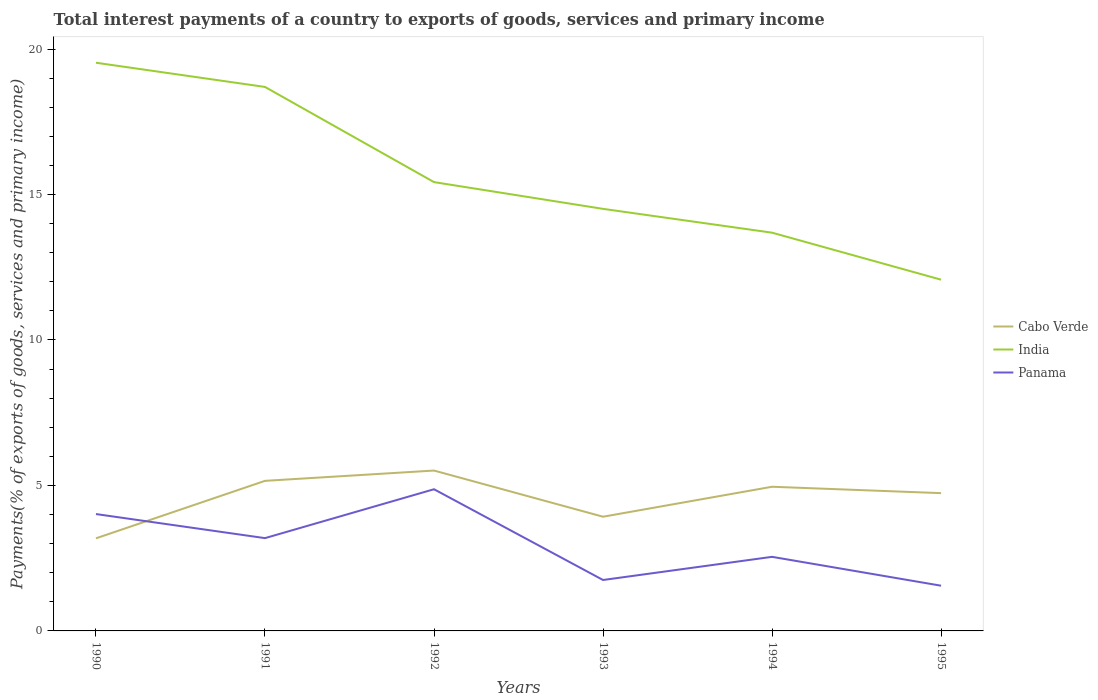Does the line corresponding to India intersect with the line corresponding to Cabo Verde?
Offer a very short reply. No. Across all years, what is the maximum total interest payments in Cabo Verde?
Keep it short and to the point. 3.18. What is the total total interest payments in Panama in the graph?
Make the answer very short. 2.27. What is the difference between the highest and the second highest total interest payments in Panama?
Keep it short and to the point. 3.32. What is the difference between two consecutive major ticks on the Y-axis?
Your answer should be very brief. 5. Does the graph contain any zero values?
Ensure brevity in your answer.  No. Where does the legend appear in the graph?
Make the answer very short. Center right. What is the title of the graph?
Keep it short and to the point. Total interest payments of a country to exports of goods, services and primary income. What is the label or title of the Y-axis?
Your response must be concise. Payments(% of exports of goods, services and primary income). What is the Payments(% of exports of goods, services and primary income) in Cabo Verde in 1990?
Provide a short and direct response. 3.18. What is the Payments(% of exports of goods, services and primary income) of India in 1990?
Give a very brief answer. 19.53. What is the Payments(% of exports of goods, services and primary income) of Panama in 1990?
Keep it short and to the point. 4.02. What is the Payments(% of exports of goods, services and primary income) in Cabo Verde in 1991?
Offer a terse response. 5.16. What is the Payments(% of exports of goods, services and primary income) of India in 1991?
Your response must be concise. 18.7. What is the Payments(% of exports of goods, services and primary income) of Panama in 1991?
Provide a short and direct response. 3.19. What is the Payments(% of exports of goods, services and primary income) in Cabo Verde in 1992?
Provide a succinct answer. 5.51. What is the Payments(% of exports of goods, services and primary income) in India in 1992?
Provide a succinct answer. 15.43. What is the Payments(% of exports of goods, services and primary income) in Panama in 1992?
Offer a very short reply. 4.87. What is the Payments(% of exports of goods, services and primary income) in Cabo Verde in 1993?
Provide a short and direct response. 3.93. What is the Payments(% of exports of goods, services and primary income) of India in 1993?
Ensure brevity in your answer.  14.51. What is the Payments(% of exports of goods, services and primary income) of Panama in 1993?
Ensure brevity in your answer.  1.75. What is the Payments(% of exports of goods, services and primary income) of Cabo Verde in 1994?
Ensure brevity in your answer.  4.96. What is the Payments(% of exports of goods, services and primary income) in India in 1994?
Your answer should be compact. 13.69. What is the Payments(% of exports of goods, services and primary income) of Panama in 1994?
Keep it short and to the point. 2.55. What is the Payments(% of exports of goods, services and primary income) in Cabo Verde in 1995?
Your answer should be compact. 4.74. What is the Payments(% of exports of goods, services and primary income) of India in 1995?
Your answer should be compact. 12.07. What is the Payments(% of exports of goods, services and primary income) in Panama in 1995?
Make the answer very short. 1.55. Across all years, what is the maximum Payments(% of exports of goods, services and primary income) in Cabo Verde?
Offer a terse response. 5.51. Across all years, what is the maximum Payments(% of exports of goods, services and primary income) of India?
Your answer should be compact. 19.53. Across all years, what is the maximum Payments(% of exports of goods, services and primary income) of Panama?
Make the answer very short. 4.87. Across all years, what is the minimum Payments(% of exports of goods, services and primary income) of Cabo Verde?
Provide a short and direct response. 3.18. Across all years, what is the minimum Payments(% of exports of goods, services and primary income) in India?
Offer a very short reply. 12.07. Across all years, what is the minimum Payments(% of exports of goods, services and primary income) in Panama?
Make the answer very short. 1.55. What is the total Payments(% of exports of goods, services and primary income) in Cabo Verde in the graph?
Keep it short and to the point. 27.47. What is the total Payments(% of exports of goods, services and primary income) of India in the graph?
Give a very brief answer. 93.93. What is the total Payments(% of exports of goods, services and primary income) of Panama in the graph?
Your answer should be very brief. 17.93. What is the difference between the Payments(% of exports of goods, services and primary income) in Cabo Verde in 1990 and that in 1991?
Provide a succinct answer. -1.98. What is the difference between the Payments(% of exports of goods, services and primary income) in India in 1990 and that in 1991?
Ensure brevity in your answer.  0.83. What is the difference between the Payments(% of exports of goods, services and primary income) in Panama in 1990 and that in 1991?
Give a very brief answer. 0.83. What is the difference between the Payments(% of exports of goods, services and primary income) in Cabo Verde in 1990 and that in 1992?
Your answer should be compact. -2.33. What is the difference between the Payments(% of exports of goods, services and primary income) of India in 1990 and that in 1992?
Provide a succinct answer. 4.1. What is the difference between the Payments(% of exports of goods, services and primary income) in Panama in 1990 and that in 1992?
Provide a succinct answer. -0.85. What is the difference between the Payments(% of exports of goods, services and primary income) of Cabo Verde in 1990 and that in 1993?
Provide a succinct answer. -0.74. What is the difference between the Payments(% of exports of goods, services and primary income) in India in 1990 and that in 1993?
Ensure brevity in your answer.  5.02. What is the difference between the Payments(% of exports of goods, services and primary income) in Panama in 1990 and that in 1993?
Ensure brevity in your answer.  2.27. What is the difference between the Payments(% of exports of goods, services and primary income) in Cabo Verde in 1990 and that in 1994?
Offer a terse response. -1.77. What is the difference between the Payments(% of exports of goods, services and primary income) of India in 1990 and that in 1994?
Your answer should be compact. 5.84. What is the difference between the Payments(% of exports of goods, services and primary income) in Panama in 1990 and that in 1994?
Your answer should be very brief. 1.47. What is the difference between the Payments(% of exports of goods, services and primary income) of Cabo Verde in 1990 and that in 1995?
Your response must be concise. -1.55. What is the difference between the Payments(% of exports of goods, services and primary income) of India in 1990 and that in 1995?
Your response must be concise. 7.46. What is the difference between the Payments(% of exports of goods, services and primary income) of Panama in 1990 and that in 1995?
Your response must be concise. 2.46. What is the difference between the Payments(% of exports of goods, services and primary income) in Cabo Verde in 1991 and that in 1992?
Keep it short and to the point. -0.35. What is the difference between the Payments(% of exports of goods, services and primary income) in India in 1991 and that in 1992?
Provide a succinct answer. 3.27. What is the difference between the Payments(% of exports of goods, services and primary income) in Panama in 1991 and that in 1992?
Keep it short and to the point. -1.68. What is the difference between the Payments(% of exports of goods, services and primary income) of Cabo Verde in 1991 and that in 1993?
Provide a short and direct response. 1.23. What is the difference between the Payments(% of exports of goods, services and primary income) in India in 1991 and that in 1993?
Offer a very short reply. 4.19. What is the difference between the Payments(% of exports of goods, services and primary income) in Panama in 1991 and that in 1993?
Your answer should be very brief. 1.44. What is the difference between the Payments(% of exports of goods, services and primary income) in Cabo Verde in 1991 and that in 1994?
Give a very brief answer. 0.2. What is the difference between the Payments(% of exports of goods, services and primary income) in India in 1991 and that in 1994?
Provide a succinct answer. 5.01. What is the difference between the Payments(% of exports of goods, services and primary income) of Panama in 1991 and that in 1994?
Your answer should be compact. 0.64. What is the difference between the Payments(% of exports of goods, services and primary income) in Cabo Verde in 1991 and that in 1995?
Ensure brevity in your answer.  0.42. What is the difference between the Payments(% of exports of goods, services and primary income) of India in 1991 and that in 1995?
Provide a short and direct response. 6.63. What is the difference between the Payments(% of exports of goods, services and primary income) in Panama in 1991 and that in 1995?
Provide a short and direct response. 1.64. What is the difference between the Payments(% of exports of goods, services and primary income) in Cabo Verde in 1992 and that in 1993?
Make the answer very short. 1.59. What is the difference between the Payments(% of exports of goods, services and primary income) in India in 1992 and that in 1993?
Give a very brief answer. 0.92. What is the difference between the Payments(% of exports of goods, services and primary income) in Panama in 1992 and that in 1993?
Provide a short and direct response. 3.12. What is the difference between the Payments(% of exports of goods, services and primary income) of Cabo Verde in 1992 and that in 1994?
Provide a short and direct response. 0.56. What is the difference between the Payments(% of exports of goods, services and primary income) of India in 1992 and that in 1994?
Provide a short and direct response. 1.74. What is the difference between the Payments(% of exports of goods, services and primary income) of Panama in 1992 and that in 1994?
Your answer should be compact. 2.32. What is the difference between the Payments(% of exports of goods, services and primary income) in Cabo Verde in 1992 and that in 1995?
Offer a very short reply. 0.78. What is the difference between the Payments(% of exports of goods, services and primary income) of India in 1992 and that in 1995?
Your answer should be very brief. 3.35. What is the difference between the Payments(% of exports of goods, services and primary income) of Panama in 1992 and that in 1995?
Provide a short and direct response. 3.32. What is the difference between the Payments(% of exports of goods, services and primary income) of Cabo Verde in 1993 and that in 1994?
Your answer should be very brief. -1.03. What is the difference between the Payments(% of exports of goods, services and primary income) of India in 1993 and that in 1994?
Offer a very short reply. 0.82. What is the difference between the Payments(% of exports of goods, services and primary income) in Panama in 1993 and that in 1994?
Your answer should be very brief. -0.8. What is the difference between the Payments(% of exports of goods, services and primary income) in Cabo Verde in 1993 and that in 1995?
Make the answer very short. -0.81. What is the difference between the Payments(% of exports of goods, services and primary income) of India in 1993 and that in 1995?
Offer a terse response. 2.43. What is the difference between the Payments(% of exports of goods, services and primary income) of Panama in 1993 and that in 1995?
Your answer should be very brief. 0.2. What is the difference between the Payments(% of exports of goods, services and primary income) in Cabo Verde in 1994 and that in 1995?
Provide a succinct answer. 0.22. What is the difference between the Payments(% of exports of goods, services and primary income) of India in 1994 and that in 1995?
Your answer should be compact. 1.62. What is the difference between the Payments(% of exports of goods, services and primary income) in Cabo Verde in 1990 and the Payments(% of exports of goods, services and primary income) in India in 1991?
Give a very brief answer. -15.52. What is the difference between the Payments(% of exports of goods, services and primary income) of Cabo Verde in 1990 and the Payments(% of exports of goods, services and primary income) of Panama in 1991?
Your answer should be very brief. -0.01. What is the difference between the Payments(% of exports of goods, services and primary income) of India in 1990 and the Payments(% of exports of goods, services and primary income) of Panama in 1991?
Your answer should be compact. 16.34. What is the difference between the Payments(% of exports of goods, services and primary income) in Cabo Verde in 1990 and the Payments(% of exports of goods, services and primary income) in India in 1992?
Your response must be concise. -12.24. What is the difference between the Payments(% of exports of goods, services and primary income) in Cabo Verde in 1990 and the Payments(% of exports of goods, services and primary income) in Panama in 1992?
Provide a succinct answer. -1.69. What is the difference between the Payments(% of exports of goods, services and primary income) of India in 1990 and the Payments(% of exports of goods, services and primary income) of Panama in 1992?
Your response must be concise. 14.66. What is the difference between the Payments(% of exports of goods, services and primary income) of Cabo Verde in 1990 and the Payments(% of exports of goods, services and primary income) of India in 1993?
Keep it short and to the point. -11.32. What is the difference between the Payments(% of exports of goods, services and primary income) in Cabo Verde in 1990 and the Payments(% of exports of goods, services and primary income) in Panama in 1993?
Offer a very short reply. 1.43. What is the difference between the Payments(% of exports of goods, services and primary income) in India in 1990 and the Payments(% of exports of goods, services and primary income) in Panama in 1993?
Give a very brief answer. 17.78. What is the difference between the Payments(% of exports of goods, services and primary income) in Cabo Verde in 1990 and the Payments(% of exports of goods, services and primary income) in India in 1994?
Your response must be concise. -10.51. What is the difference between the Payments(% of exports of goods, services and primary income) in Cabo Verde in 1990 and the Payments(% of exports of goods, services and primary income) in Panama in 1994?
Offer a terse response. 0.64. What is the difference between the Payments(% of exports of goods, services and primary income) of India in 1990 and the Payments(% of exports of goods, services and primary income) of Panama in 1994?
Your answer should be compact. 16.98. What is the difference between the Payments(% of exports of goods, services and primary income) of Cabo Verde in 1990 and the Payments(% of exports of goods, services and primary income) of India in 1995?
Give a very brief answer. -8.89. What is the difference between the Payments(% of exports of goods, services and primary income) in Cabo Verde in 1990 and the Payments(% of exports of goods, services and primary income) in Panama in 1995?
Your response must be concise. 1.63. What is the difference between the Payments(% of exports of goods, services and primary income) of India in 1990 and the Payments(% of exports of goods, services and primary income) of Panama in 1995?
Provide a succinct answer. 17.98. What is the difference between the Payments(% of exports of goods, services and primary income) in Cabo Verde in 1991 and the Payments(% of exports of goods, services and primary income) in India in 1992?
Provide a succinct answer. -10.27. What is the difference between the Payments(% of exports of goods, services and primary income) of Cabo Verde in 1991 and the Payments(% of exports of goods, services and primary income) of Panama in 1992?
Give a very brief answer. 0.29. What is the difference between the Payments(% of exports of goods, services and primary income) in India in 1991 and the Payments(% of exports of goods, services and primary income) in Panama in 1992?
Your answer should be very brief. 13.83. What is the difference between the Payments(% of exports of goods, services and primary income) of Cabo Verde in 1991 and the Payments(% of exports of goods, services and primary income) of India in 1993?
Offer a terse response. -9.35. What is the difference between the Payments(% of exports of goods, services and primary income) in Cabo Verde in 1991 and the Payments(% of exports of goods, services and primary income) in Panama in 1993?
Give a very brief answer. 3.41. What is the difference between the Payments(% of exports of goods, services and primary income) in India in 1991 and the Payments(% of exports of goods, services and primary income) in Panama in 1993?
Offer a terse response. 16.95. What is the difference between the Payments(% of exports of goods, services and primary income) in Cabo Verde in 1991 and the Payments(% of exports of goods, services and primary income) in India in 1994?
Offer a terse response. -8.53. What is the difference between the Payments(% of exports of goods, services and primary income) of Cabo Verde in 1991 and the Payments(% of exports of goods, services and primary income) of Panama in 1994?
Keep it short and to the point. 2.61. What is the difference between the Payments(% of exports of goods, services and primary income) in India in 1991 and the Payments(% of exports of goods, services and primary income) in Panama in 1994?
Provide a short and direct response. 16.15. What is the difference between the Payments(% of exports of goods, services and primary income) of Cabo Verde in 1991 and the Payments(% of exports of goods, services and primary income) of India in 1995?
Provide a succinct answer. -6.91. What is the difference between the Payments(% of exports of goods, services and primary income) in Cabo Verde in 1991 and the Payments(% of exports of goods, services and primary income) in Panama in 1995?
Provide a succinct answer. 3.6. What is the difference between the Payments(% of exports of goods, services and primary income) of India in 1991 and the Payments(% of exports of goods, services and primary income) of Panama in 1995?
Keep it short and to the point. 17.14. What is the difference between the Payments(% of exports of goods, services and primary income) of Cabo Verde in 1992 and the Payments(% of exports of goods, services and primary income) of India in 1993?
Keep it short and to the point. -9. What is the difference between the Payments(% of exports of goods, services and primary income) of Cabo Verde in 1992 and the Payments(% of exports of goods, services and primary income) of Panama in 1993?
Make the answer very short. 3.76. What is the difference between the Payments(% of exports of goods, services and primary income) of India in 1992 and the Payments(% of exports of goods, services and primary income) of Panama in 1993?
Give a very brief answer. 13.68. What is the difference between the Payments(% of exports of goods, services and primary income) of Cabo Verde in 1992 and the Payments(% of exports of goods, services and primary income) of India in 1994?
Keep it short and to the point. -8.18. What is the difference between the Payments(% of exports of goods, services and primary income) in Cabo Verde in 1992 and the Payments(% of exports of goods, services and primary income) in Panama in 1994?
Keep it short and to the point. 2.97. What is the difference between the Payments(% of exports of goods, services and primary income) in India in 1992 and the Payments(% of exports of goods, services and primary income) in Panama in 1994?
Your response must be concise. 12.88. What is the difference between the Payments(% of exports of goods, services and primary income) of Cabo Verde in 1992 and the Payments(% of exports of goods, services and primary income) of India in 1995?
Your answer should be very brief. -6.56. What is the difference between the Payments(% of exports of goods, services and primary income) in Cabo Verde in 1992 and the Payments(% of exports of goods, services and primary income) in Panama in 1995?
Provide a short and direct response. 3.96. What is the difference between the Payments(% of exports of goods, services and primary income) of India in 1992 and the Payments(% of exports of goods, services and primary income) of Panama in 1995?
Offer a very short reply. 13.87. What is the difference between the Payments(% of exports of goods, services and primary income) of Cabo Verde in 1993 and the Payments(% of exports of goods, services and primary income) of India in 1994?
Provide a succinct answer. -9.76. What is the difference between the Payments(% of exports of goods, services and primary income) in Cabo Verde in 1993 and the Payments(% of exports of goods, services and primary income) in Panama in 1994?
Give a very brief answer. 1.38. What is the difference between the Payments(% of exports of goods, services and primary income) in India in 1993 and the Payments(% of exports of goods, services and primary income) in Panama in 1994?
Your answer should be compact. 11.96. What is the difference between the Payments(% of exports of goods, services and primary income) in Cabo Verde in 1993 and the Payments(% of exports of goods, services and primary income) in India in 1995?
Offer a terse response. -8.15. What is the difference between the Payments(% of exports of goods, services and primary income) of Cabo Verde in 1993 and the Payments(% of exports of goods, services and primary income) of Panama in 1995?
Ensure brevity in your answer.  2.37. What is the difference between the Payments(% of exports of goods, services and primary income) of India in 1993 and the Payments(% of exports of goods, services and primary income) of Panama in 1995?
Provide a short and direct response. 12.95. What is the difference between the Payments(% of exports of goods, services and primary income) in Cabo Verde in 1994 and the Payments(% of exports of goods, services and primary income) in India in 1995?
Offer a very short reply. -7.12. What is the difference between the Payments(% of exports of goods, services and primary income) of Cabo Verde in 1994 and the Payments(% of exports of goods, services and primary income) of Panama in 1995?
Ensure brevity in your answer.  3.4. What is the difference between the Payments(% of exports of goods, services and primary income) of India in 1994 and the Payments(% of exports of goods, services and primary income) of Panama in 1995?
Your answer should be very brief. 12.13. What is the average Payments(% of exports of goods, services and primary income) of Cabo Verde per year?
Give a very brief answer. 4.58. What is the average Payments(% of exports of goods, services and primary income) in India per year?
Keep it short and to the point. 15.65. What is the average Payments(% of exports of goods, services and primary income) of Panama per year?
Ensure brevity in your answer.  2.99. In the year 1990, what is the difference between the Payments(% of exports of goods, services and primary income) in Cabo Verde and Payments(% of exports of goods, services and primary income) in India?
Make the answer very short. -16.35. In the year 1990, what is the difference between the Payments(% of exports of goods, services and primary income) of Cabo Verde and Payments(% of exports of goods, services and primary income) of Panama?
Ensure brevity in your answer.  -0.83. In the year 1990, what is the difference between the Payments(% of exports of goods, services and primary income) in India and Payments(% of exports of goods, services and primary income) in Panama?
Offer a terse response. 15.51. In the year 1991, what is the difference between the Payments(% of exports of goods, services and primary income) of Cabo Verde and Payments(% of exports of goods, services and primary income) of India?
Provide a succinct answer. -13.54. In the year 1991, what is the difference between the Payments(% of exports of goods, services and primary income) of Cabo Verde and Payments(% of exports of goods, services and primary income) of Panama?
Provide a succinct answer. 1.97. In the year 1991, what is the difference between the Payments(% of exports of goods, services and primary income) in India and Payments(% of exports of goods, services and primary income) in Panama?
Offer a terse response. 15.51. In the year 1992, what is the difference between the Payments(% of exports of goods, services and primary income) in Cabo Verde and Payments(% of exports of goods, services and primary income) in India?
Give a very brief answer. -9.91. In the year 1992, what is the difference between the Payments(% of exports of goods, services and primary income) of Cabo Verde and Payments(% of exports of goods, services and primary income) of Panama?
Offer a very short reply. 0.64. In the year 1992, what is the difference between the Payments(% of exports of goods, services and primary income) in India and Payments(% of exports of goods, services and primary income) in Panama?
Your answer should be compact. 10.56. In the year 1993, what is the difference between the Payments(% of exports of goods, services and primary income) of Cabo Verde and Payments(% of exports of goods, services and primary income) of India?
Your response must be concise. -10.58. In the year 1993, what is the difference between the Payments(% of exports of goods, services and primary income) of Cabo Verde and Payments(% of exports of goods, services and primary income) of Panama?
Provide a succinct answer. 2.17. In the year 1993, what is the difference between the Payments(% of exports of goods, services and primary income) of India and Payments(% of exports of goods, services and primary income) of Panama?
Your answer should be compact. 12.76. In the year 1994, what is the difference between the Payments(% of exports of goods, services and primary income) in Cabo Verde and Payments(% of exports of goods, services and primary income) in India?
Provide a short and direct response. -8.73. In the year 1994, what is the difference between the Payments(% of exports of goods, services and primary income) in Cabo Verde and Payments(% of exports of goods, services and primary income) in Panama?
Provide a short and direct response. 2.41. In the year 1994, what is the difference between the Payments(% of exports of goods, services and primary income) in India and Payments(% of exports of goods, services and primary income) in Panama?
Offer a terse response. 11.14. In the year 1995, what is the difference between the Payments(% of exports of goods, services and primary income) of Cabo Verde and Payments(% of exports of goods, services and primary income) of India?
Give a very brief answer. -7.34. In the year 1995, what is the difference between the Payments(% of exports of goods, services and primary income) of Cabo Verde and Payments(% of exports of goods, services and primary income) of Panama?
Keep it short and to the point. 3.18. In the year 1995, what is the difference between the Payments(% of exports of goods, services and primary income) of India and Payments(% of exports of goods, services and primary income) of Panama?
Your answer should be very brief. 10.52. What is the ratio of the Payments(% of exports of goods, services and primary income) of Cabo Verde in 1990 to that in 1991?
Offer a very short reply. 0.62. What is the ratio of the Payments(% of exports of goods, services and primary income) in India in 1990 to that in 1991?
Keep it short and to the point. 1.04. What is the ratio of the Payments(% of exports of goods, services and primary income) in Panama in 1990 to that in 1991?
Keep it short and to the point. 1.26. What is the ratio of the Payments(% of exports of goods, services and primary income) in Cabo Verde in 1990 to that in 1992?
Provide a succinct answer. 0.58. What is the ratio of the Payments(% of exports of goods, services and primary income) in India in 1990 to that in 1992?
Your response must be concise. 1.27. What is the ratio of the Payments(% of exports of goods, services and primary income) in Panama in 1990 to that in 1992?
Your answer should be very brief. 0.82. What is the ratio of the Payments(% of exports of goods, services and primary income) in Cabo Verde in 1990 to that in 1993?
Your answer should be compact. 0.81. What is the ratio of the Payments(% of exports of goods, services and primary income) in India in 1990 to that in 1993?
Offer a terse response. 1.35. What is the ratio of the Payments(% of exports of goods, services and primary income) in Panama in 1990 to that in 1993?
Your answer should be compact. 2.29. What is the ratio of the Payments(% of exports of goods, services and primary income) in Cabo Verde in 1990 to that in 1994?
Your answer should be compact. 0.64. What is the ratio of the Payments(% of exports of goods, services and primary income) in India in 1990 to that in 1994?
Give a very brief answer. 1.43. What is the ratio of the Payments(% of exports of goods, services and primary income) of Panama in 1990 to that in 1994?
Provide a short and direct response. 1.58. What is the ratio of the Payments(% of exports of goods, services and primary income) in Cabo Verde in 1990 to that in 1995?
Your answer should be very brief. 0.67. What is the ratio of the Payments(% of exports of goods, services and primary income) of India in 1990 to that in 1995?
Your answer should be compact. 1.62. What is the ratio of the Payments(% of exports of goods, services and primary income) in Panama in 1990 to that in 1995?
Give a very brief answer. 2.58. What is the ratio of the Payments(% of exports of goods, services and primary income) in Cabo Verde in 1991 to that in 1992?
Give a very brief answer. 0.94. What is the ratio of the Payments(% of exports of goods, services and primary income) in India in 1991 to that in 1992?
Provide a succinct answer. 1.21. What is the ratio of the Payments(% of exports of goods, services and primary income) of Panama in 1991 to that in 1992?
Your answer should be very brief. 0.66. What is the ratio of the Payments(% of exports of goods, services and primary income) in Cabo Verde in 1991 to that in 1993?
Your answer should be very brief. 1.31. What is the ratio of the Payments(% of exports of goods, services and primary income) of India in 1991 to that in 1993?
Offer a very short reply. 1.29. What is the ratio of the Payments(% of exports of goods, services and primary income) of Panama in 1991 to that in 1993?
Your answer should be very brief. 1.82. What is the ratio of the Payments(% of exports of goods, services and primary income) of Cabo Verde in 1991 to that in 1994?
Offer a terse response. 1.04. What is the ratio of the Payments(% of exports of goods, services and primary income) in India in 1991 to that in 1994?
Make the answer very short. 1.37. What is the ratio of the Payments(% of exports of goods, services and primary income) of Panama in 1991 to that in 1994?
Your answer should be very brief. 1.25. What is the ratio of the Payments(% of exports of goods, services and primary income) of Cabo Verde in 1991 to that in 1995?
Keep it short and to the point. 1.09. What is the ratio of the Payments(% of exports of goods, services and primary income) in India in 1991 to that in 1995?
Ensure brevity in your answer.  1.55. What is the ratio of the Payments(% of exports of goods, services and primary income) of Panama in 1991 to that in 1995?
Keep it short and to the point. 2.05. What is the ratio of the Payments(% of exports of goods, services and primary income) of Cabo Verde in 1992 to that in 1993?
Your response must be concise. 1.4. What is the ratio of the Payments(% of exports of goods, services and primary income) in India in 1992 to that in 1993?
Your response must be concise. 1.06. What is the ratio of the Payments(% of exports of goods, services and primary income) in Panama in 1992 to that in 1993?
Provide a succinct answer. 2.78. What is the ratio of the Payments(% of exports of goods, services and primary income) in Cabo Verde in 1992 to that in 1994?
Provide a short and direct response. 1.11. What is the ratio of the Payments(% of exports of goods, services and primary income) in India in 1992 to that in 1994?
Keep it short and to the point. 1.13. What is the ratio of the Payments(% of exports of goods, services and primary income) in Panama in 1992 to that in 1994?
Give a very brief answer. 1.91. What is the ratio of the Payments(% of exports of goods, services and primary income) in Cabo Verde in 1992 to that in 1995?
Your answer should be compact. 1.16. What is the ratio of the Payments(% of exports of goods, services and primary income) in India in 1992 to that in 1995?
Make the answer very short. 1.28. What is the ratio of the Payments(% of exports of goods, services and primary income) of Panama in 1992 to that in 1995?
Your answer should be compact. 3.13. What is the ratio of the Payments(% of exports of goods, services and primary income) in Cabo Verde in 1993 to that in 1994?
Provide a short and direct response. 0.79. What is the ratio of the Payments(% of exports of goods, services and primary income) of India in 1993 to that in 1994?
Keep it short and to the point. 1.06. What is the ratio of the Payments(% of exports of goods, services and primary income) in Panama in 1993 to that in 1994?
Make the answer very short. 0.69. What is the ratio of the Payments(% of exports of goods, services and primary income) in Cabo Verde in 1993 to that in 1995?
Your answer should be compact. 0.83. What is the ratio of the Payments(% of exports of goods, services and primary income) of India in 1993 to that in 1995?
Your answer should be very brief. 1.2. What is the ratio of the Payments(% of exports of goods, services and primary income) of Panama in 1993 to that in 1995?
Offer a terse response. 1.13. What is the ratio of the Payments(% of exports of goods, services and primary income) in Cabo Verde in 1994 to that in 1995?
Offer a terse response. 1.05. What is the ratio of the Payments(% of exports of goods, services and primary income) in India in 1994 to that in 1995?
Provide a succinct answer. 1.13. What is the ratio of the Payments(% of exports of goods, services and primary income) of Panama in 1994 to that in 1995?
Your answer should be compact. 1.64. What is the difference between the highest and the second highest Payments(% of exports of goods, services and primary income) in Cabo Verde?
Your response must be concise. 0.35. What is the difference between the highest and the second highest Payments(% of exports of goods, services and primary income) of India?
Offer a very short reply. 0.83. What is the difference between the highest and the second highest Payments(% of exports of goods, services and primary income) in Panama?
Your answer should be very brief. 0.85. What is the difference between the highest and the lowest Payments(% of exports of goods, services and primary income) of Cabo Verde?
Your response must be concise. 2.33. What is the difference between the highest and the lowest Payments(% of exports of goods, services and primary income) of India?
Make the answer very short. 7.46. What is the difference between the highest and the lowest Payments(% of exports of goods, services and primary income) of Panama?
Ensure brevity in your answer.  3.32. 